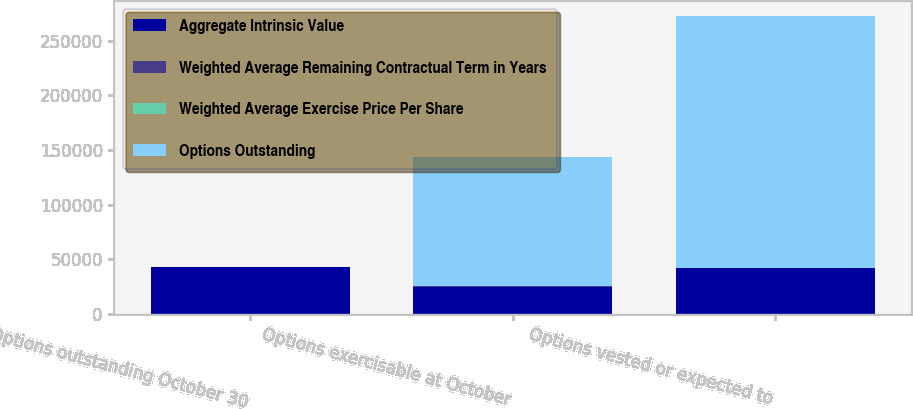<chart> <loc_0><loc_0><loc_500><loc_500><stacked_bar_chart><ecel><fcel>Options outstanding October 30<fcel>Options exercisable at October<fcel>Options vested or expected to<nl><fcel>Aggregate Intrinsic Value<fcel>43079<fcel>24994<fcel>41975<nl><fcel>Weighted Average Remaining Contractual Term in Years<fcel>29.87<fcel>31.85<fcel>29.95<nl><fcel>Weighted Average Exercise Price Per Share<fcel>4.6<fcel>3.3<fcel>4.5<nl><fcel>Options Outstanding<fcel>31.85<fcel>118811<fcel>230805<nl></chart> 